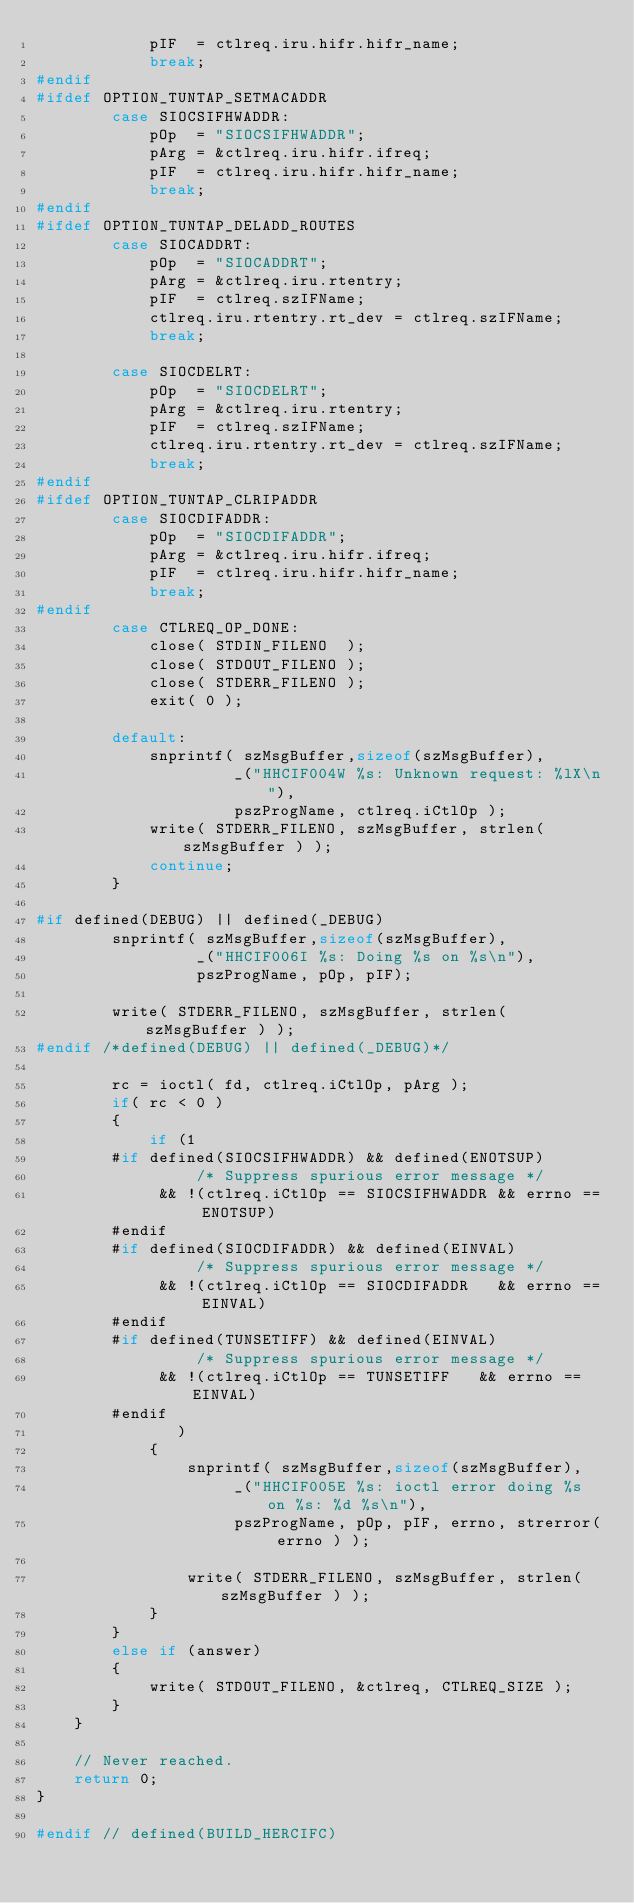Convert code to text. <code><loc_0><loc_0><loc_500><loc_500><_C_>            pIF  = ctlreq.iru.hifr.hifr_name;
            break;
#endif
#ifdef OPTION_TUNTAP_SETMACADDR
        case SIOCSIFHWADDR:
            pOp  = "SIOCSIFHWADDR";
            pArg = &ctlreq.iru.hifr.ifreq;
            pIF  = ctlreq.iru.hifr.hifr_name;
            break;
#endif
#ifdef OPTION_TUNTAP_DELADD_ROUTES
        case SIOCADDRT:
            pOp  = "SIOCADDRT";
            pArg = &ctlreq.iru.rtentry;
            pIF  = ctlreq.szIFName;
            ctlreq.iru.rtentry.rt_dev = ctlreq.szIFName;
            break;

        case SIOCDELRT:
            pOp  = "SIOCDELRT";
            pArg = &ctlreq.iru.rtentry;
            pIF  = ctlreq.szIFName;
            ctlreq.iru.rtentry.rt_dev = ctlreq.szIFName;
            break;
#endif
#ifdef OPTION_TUNTAP_CLRIPADDR
        case SIOCDIFADDR:
            pOp  = "SIOCDIFADDR";
            pArg = &ctlreq.iru.hifr.ifreq;
            pIF  = ctlreq.iru.hifr.hifr_name;
            break;
#endif
        case CTLREQ_OP_DONE:
            close( STDIN_FILENO  );
            close( STDOUT_FILENO );
            close( STDERR_FILENO );
            exit( 0 );

        default:
            snprintf( szMsgBuffer,sizeof(szMsgBuffer),
                     _("HHCIF004W %s: Unknown request: %lX\n"),
                     pszProgName, ctlreq.iCtlOp );
            write( STDERR_FILENO, szMsgBuffer, strlen( szMsgBuffer ) );
            continue;
        }

#if defined(DEBUG) || defined(_DEBUG)
        snprintf( szMsgBuffer,sizeof(szMsgBuffer),
                 _("HHCIF006I %s: Doing %s on %s\n"),
                 pszProgName, pOp, pIF);

        write( STDERR_FILENO, szMsgBuffer, strlen( szMsgBuffer ) );
#endif /*defined(DEBUG) || defined(_DEBUG)*/

        rc = ioctl( fd, ctlreq.iCtlOp, pArg );
        if( rc < 0 )
        {
            if (1
        #if defined(SIOCSIFHWADDR) && defined(ENOTSUP)
                 /* Suppress spurious error message */
             && !(ctlreq.iCtlOp == SIOCSIFHWADDR && errno == ENOTSUP)
        #endif
        #if defined(SIOCDIFADDR) && defined(EINVAL)
                 /* Suppress spurious error message */
             && !(ctlreq.iCtlOp == SIOCDIFADDR   && errno == EINVAL)
        #endif
        #if defined(TUNSETIFF) && defined(EINVAL)
                 /* Suppress spurious error message */
             && !(ctlreq.iCtlOp == TUNSETIFF   && errno == EINVAL)
        #endif
               )
            {
                snprintf( szMsgBuffer,sizeof(szMsgBuffer),
                     _("HHCIF005E %s: ioctl error doing %s on %s: %d %s\n"),
                     pszProgName, pOp, pIF, errno, strerror( errno ) );

                write( STDERR_FILENO, szMsgBuffer, strlen( szMsgBuffer ) );
            }
        }
        else if (answer)
        {
            write( STDOUT_FILENO, &ctlreq, CTLREQ_SIZE );
        }
    }

    // Never reached.
    return 0;
}

#endif // defined(BUILD_HERCIFC)

</code> 